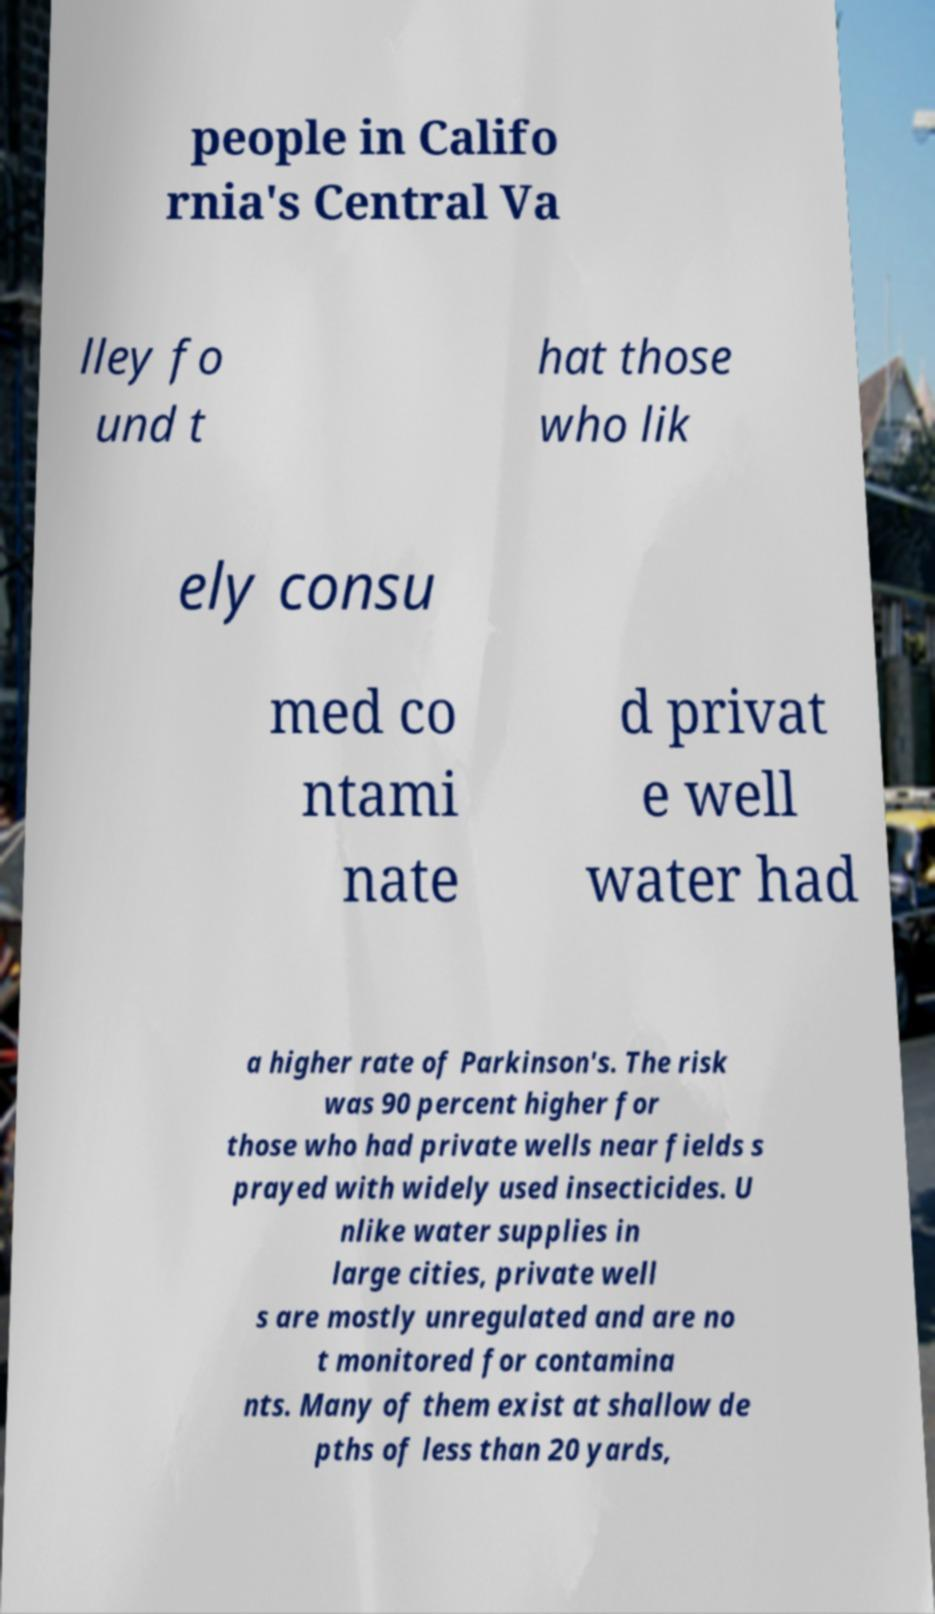Can you read and provide the text displayed in the image?This photo seems to have some interesting text. Can you extract and type it out for me? people in Califo rnia's Central Va lley fo und t hat those who lik ely consu med co ntami nate d privat e well water had a higher rate of Parkinson's. The risk was 90 percent higher for those who had private wells near fields s prayed with widely used insecticides. U nlike water supplies in large cities, private well s are mostly unregulated and are no t monitored for contamina nts. Many of them exist at shallow de pths of less than 20 yards, 